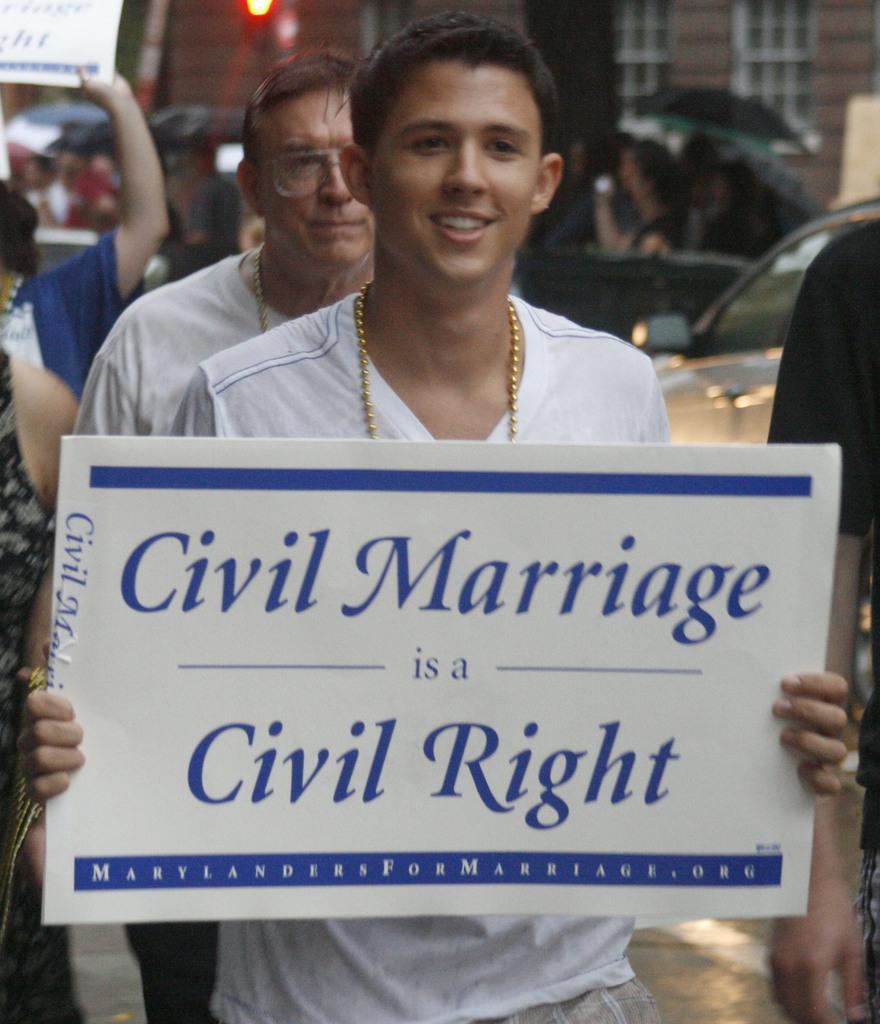How would you summarize this image in a sentence or two? This picture is clicked outside and we can see the group of persons. In the foreground we can see a person wearing white color t-shirt and holding a banner on which we can see the text. In the background we can see the building and the vehicles and we can see the group of persons and umbrellas and we can see the light and some other objects. 